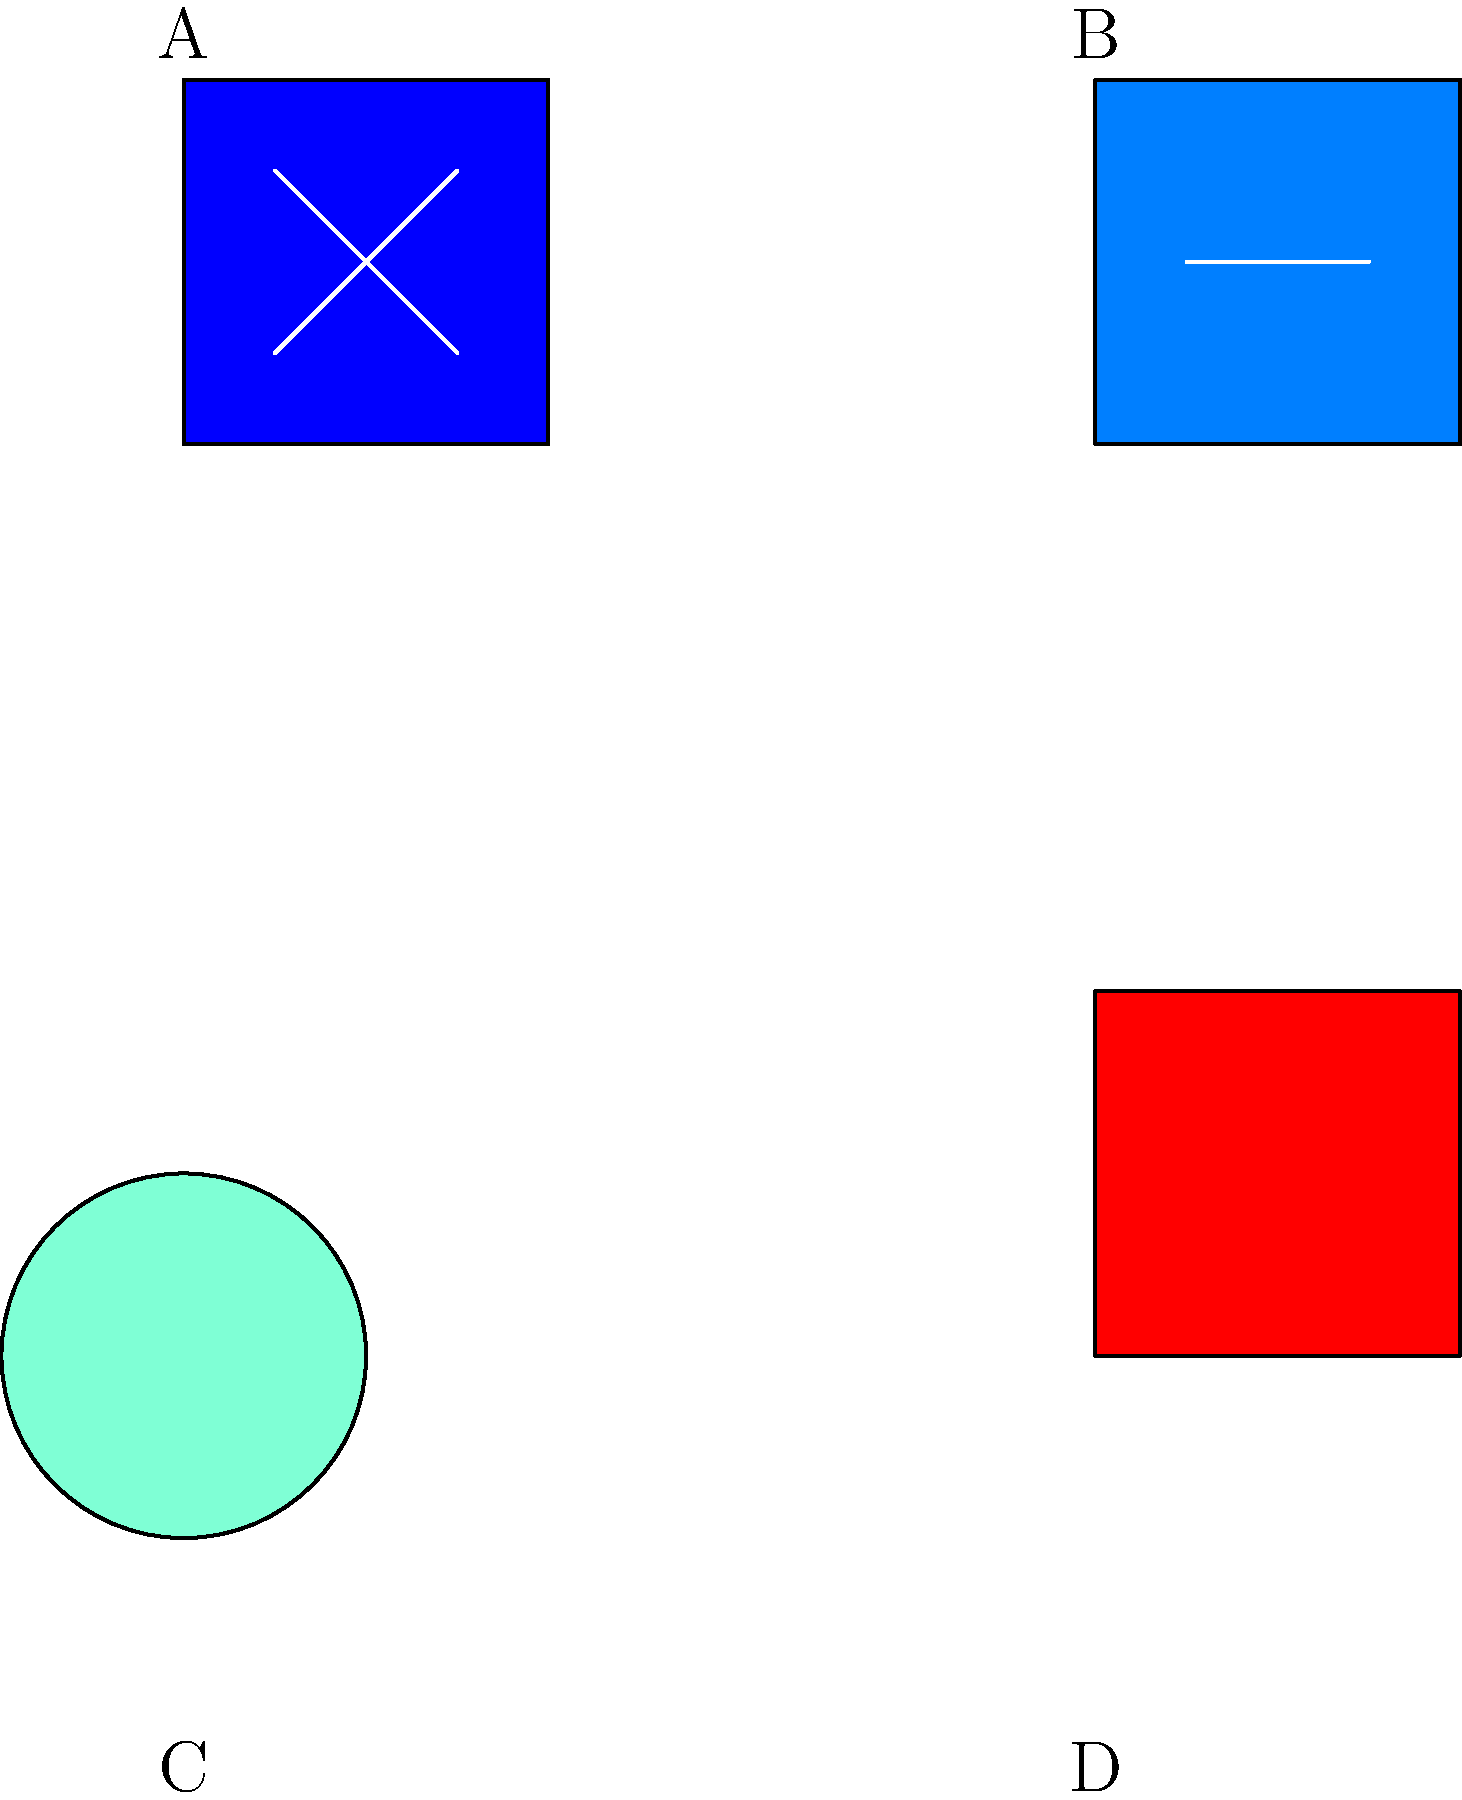Identify the NFL team logos shown in the image above, where parts of each logo have been intentionally omitted. Match the letters A, B, C, and D to the correct team names: New England Patriots, Dallas Cowboys, Green Bay Packers, and San Francisco 49ers. To identify the partially shown NFL team logos, we need to analyze the visible elements and colors of each logo:

1. Logo A: This logo shows a blue square with white diagonal lines forming an 'X'. This is characteristic of the New England Patriots logo, which features a stylized patriot face with a blue background and white star.

2. Logo B: We can see a dark blue rectangle with a single white horizontal line. This is part of the Dallas Cowboys' iconic star logo, where the white line represents one of the star's points.

3. Logo C: This logo displays a green circle, which is the base of the Green Bay Packers' 'G' logo. The Packers are known for their simple yet recognizable circular 'G' emblem.

4. Logo D: A solid red square is shown, which is the background color of the San Francisco 49ers logo. The 49ers use a bright red as their primary color in their oval-shaped logo containing "SF" and "49ers" text.

Therefore, the correct matching is:
A - New England Patriots
B - Dallas Cowboys
C - Green Bay Packers
D - San Francisco 49ers
Answer: A: Patriots, B: Cowboys, C: Packers, D: 49ers 